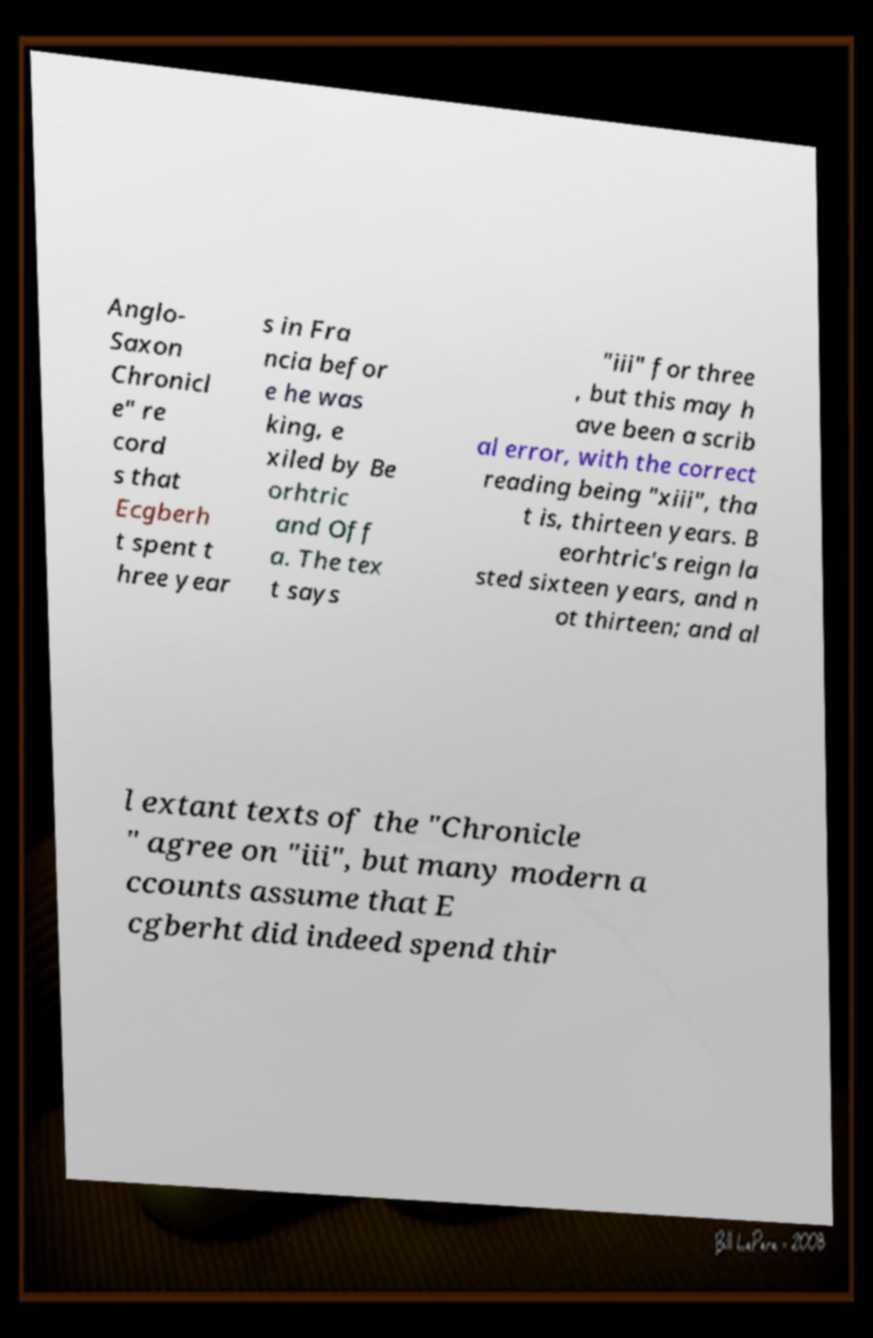What messages or text are displayed in this image? I need them in a readable, typed format. Anglo- Saxon Chronicl e" re cord s that Ecgberh t spent t hree year s in Fra ncia befor e he was king, e xiled by Be orhtric and Off a. The tex t says "iii" for three , but this may h ave been a scrib al error, with the correct reading being "xiii", tha t is, thirteen years. B eorhtric's reign la sted sixteen years, and n ot thirteen; and al l extant texts of the "Chronicle " agree on "iii", but many modern a ccounts assume that E cgberht did indeed spend thir 